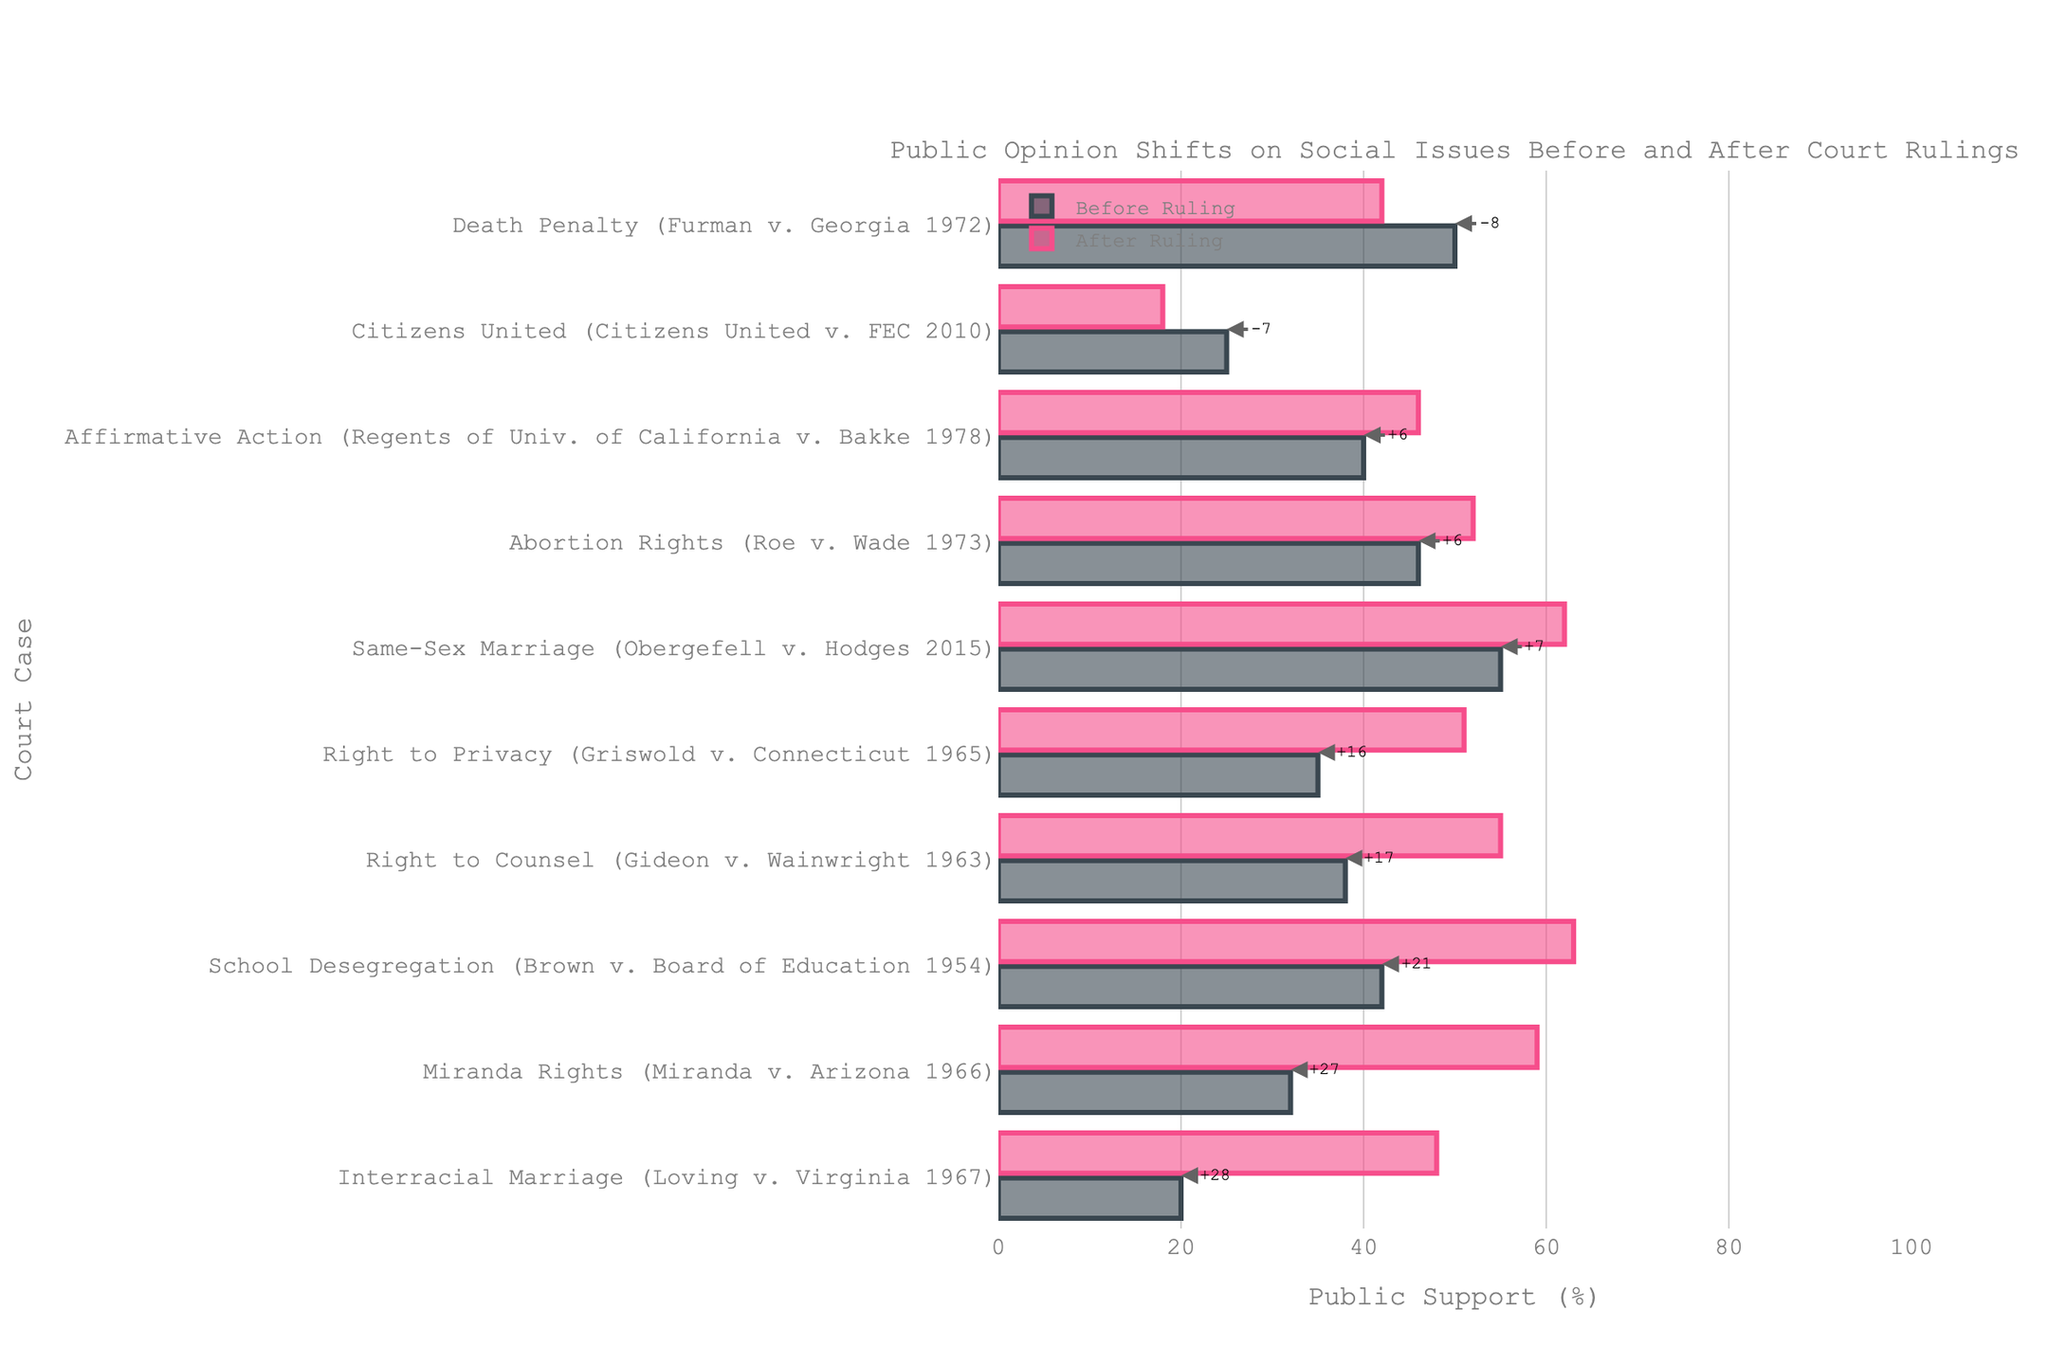What is the difference in public support for Same-Sex Marriage before and after the ruling? The public support for Same-Sex Marriage was 55% before the ruling and increased to 62% after the ruling. The difference can be calculated by subtracting the 'Before Ruling' value from the 'After Ruling' value, i.e., 62 - 55.
Answer: 7% Which issue saw the largest increase in public support after the ruling? To determine the largest increase, look for the issue with the highest positive change in support. The chart shows that School Desegregation (Brown v. Board of Education 1954) had a significant increase from 42% to 63%. The increase is 21%.
Answer: School Desegregation Which issue experienced a decline in public support after the ruling? The chart shows the changes in public support before and after each ruling. The issue that experienced a decline is the Death Penalty (Furman v. Georgia 1972), where the support dropped from 50% to 42%, as well as Citizens United (Citizens United v. FEC 2010) where support fell from 25% to 18%.
Answer: Death Penalty and Citizens United How many issues showed an increase in public support after the ruling? Count the number of issues where the 'After Ruling' value is greater than the 'Before Ruling' value. By examining the chart, observe that there are seven issues where support increased.
Answer: 7 Which case saw the least change in public support? Examine the chart and look for the issue with the smallest difference between 'Before Ruling' and 'After Ruling'. Affirmative Action (Regents of Univ. of California v. Bakke 1978) saw the smallest change, with a difference of just 6%.
Answer: Affirmative Action Which ruling had higher public support before the ruling than after? Identify the issues where the 'Before Ruling' support is higher than the 'After Ruling' support. Both Citizens United and Death Penalty had higher support before the ruling than after.
Answer: Citizens United and Death Penalty What is the average public support for Same-Sex Marriage before and after the ruling? To find the average public support before and after the ruling for Same-Sex Marriage, sum the values before and after the ruling (55 + 62) and divide by 2.
Answer: 58.5 